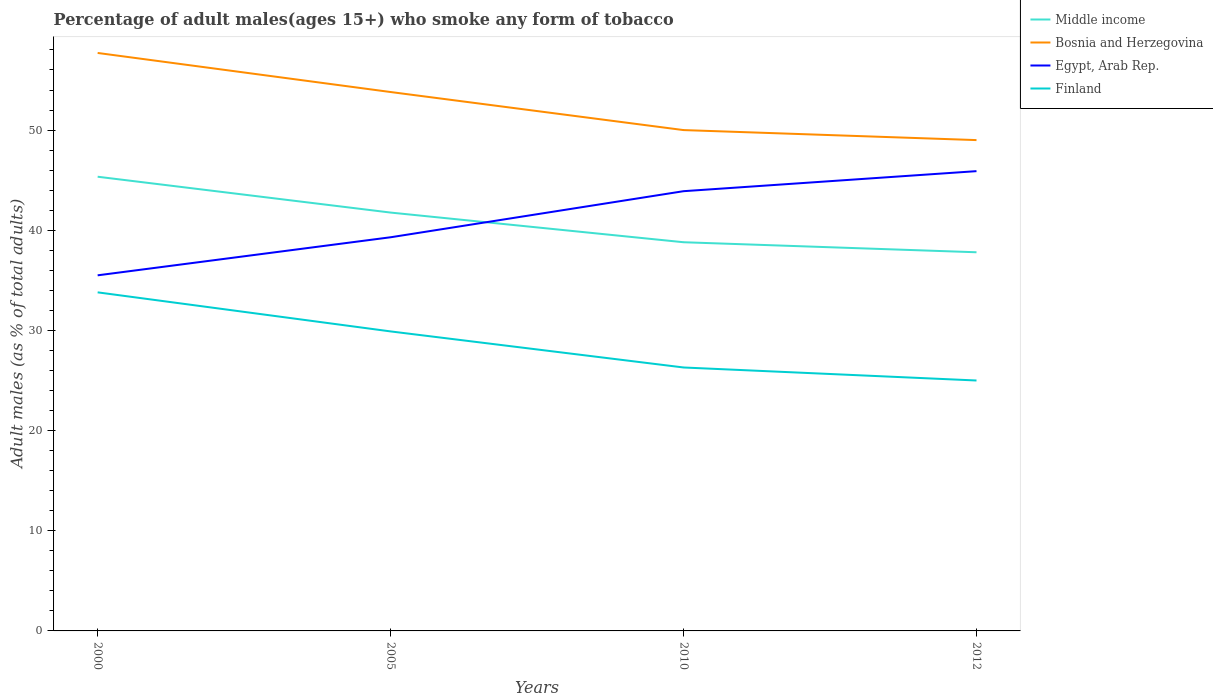How many different coloured lines are there?
Your response must be concise. 4. Does the line corresponding to Bosnia and Herzegovina intersect with the line corresponding to Middle income?
Ensure brevity in your answer.  No. Across all years, what is the maximum percentage of adult males who smoke in Middle income?
Your answer should be very brief. 37.8. What is the total percentage of adult males who smoke in Middle income in the graph?
Give a very brief answer. 2.96. What is the difference between the highest and the second highest percentage of adult males who smoke in Middle income?
Your answer should be very brief. 7.54. How many years are there in the graph?
Make the answer very short. 4. What is the title of the graph?
Provide a short and direct response. Percentage of adult males(ages 15+) who smoke any form of tobacco. What is the label or title of the X-axis?
Ensure brevity in your answer.  Years. What is the label or title of the Y-axis?
Ensure brevity in your answer.  Adult males (as % of total adults). What is the Adult males (as % of total adults) in Middle income in 2000?
Provide a short and direct response. 45.34. What is the Adult males (as % of total adults) of Bosnia and Herzegovina in 2000?
Provide a short and direct response. 57.7. What is the Adult males (as % of total adults) of Egypt, Arab Rep. in 2000?
Your answer should be very brief. 35.5. What is the Adult males (as % of total adults) of Finland in 2000?
Offer a terse response. 33.8. What is the Adult males (as % of total adults) of Middle income in 2005?
Your answer should be very brief. 41.77. What is the Adult males (as % of total adults) of Bosnia and Herzegovina in 2005?
Your answer should be very brief. 53.8. What is the Adult males (as % of total adults) of Egypt, Arab Rep. in 2005?
Offer a terse response. 39.3. What is the Adult males (as % of total adults) of Finland in 2005?
Give a very brief answer. 29.9. What is the Adult males (as % of total adults) of Middle income in 2010?
Give a very brief answer. 38.8. What is the Adult males (as % of total adults) of Egypt, Arab Rep. in 2010?
Ensure brevity in your answer.  43.9. What is the Adult males (as % of total adults) of Finland in 2010?
Keep it short and to the point. 26.3. What is the Adult males (as % of total adults) in Middle income in 2012?
Your answer should be compact. 37.8. What is the Adult males (as % of total adults) in Egypt, Arab Rep. in 2012?
Ensure brevity in your answer.  45.9. What is the Adult males (as % of total adults) of Finland in 2012?
Give a very brief answer. 25. Across all years, what is the maximum Adult males (as % of total adults) of Middle income?
Provide a succinct answer. 45.34. Across all years, what is the maximum Adult males (as % of total adults) in Bosnia and Herzegovina?
Provide a succinct answer. 57.7. Across all years, what is the maximum Adult males (as % of total adults) in Egypt, Arab Rep.?
Your answer should be compact. 45.9. Across all years, what is the maximum Adult males (as % of total adults) in Finland?
Provide a succinct answer. 33.8. Across all years, what is the minimum Adult males (as % of total adults) in Middle income?
Your answer should be compact. 37.8. Across all years, what is the minimum Adult males (as % of total adults) in Bosnia and Herzegovina?
Provide a short and direct response. 49. Across all years, what is the minimum Adult males (as % of total adults) in Egypt, Arab Rep.?
Your answer should be very brief. 35.5. Across all years, what is the minimum Adult males (as % of total adults) in Finland?
Make the answer very short. 25. What is the total Adult males (as % of total adults) in Middle income in the graph?
Make the answer very short. 163.71. What is the total Adult males (as % of total adults) of Bosnia and Herzegovina in the graph?
Offer a very short reply. 210.5. What is the total Adult males (as % of total adults) in Egypt, Arab Rep. in the graph?
Ensure brevity in your answer.  164.6. What is the total Adult males (as % of total adults) in Finland in the graph?
Your response must be concise. 115. What is the difference between the Adult males (as % of total adults) of Middle income in 2000 and that in 2005?
Ensure brevity in your answer.  3.58. What is the difference between the Adult males (as % of total adults) of Egypt, Arab Rep. in 2000 and that in 2005?
Your answer should be very brief. -3.8. What is the difference between the Adult males (as % of total adults) of Finland in 2000 and that in 2005?
Give a very brief answer. 3.9. What is the difference between the Adult males (as % of total adults) of Middle income in 2000 and that in 2010?
Provide a succinct answer. 6.54. What is the difference between the Adult males (as % of total adults) of Bosnia and Herzegovina in 2000 and that in 2010?
Your answer should be compact. 7.7. What is the difference between the Adult males (as % of total adults) in Middle income in 2000 and that in 2012?
Ensure brevity in your answer.  7.54. What is the difference between the Adult males (as % of total adults) in Bosnia and Herzegovina in 2000 and that in 2012?
Keep it short and to the point. 8.7. What is the difference between the Adult males (as % of total adults) of Finland in 2000 and that in 2012?
Your response must be concise. 8.8. What is the difference between the Adult males (as % of total adults) in Middle income in 2005 and that in 2010?
Give a very brief answer. 2.96. What is the difference between the Adult males (as % of total adults) in Bosnia and Herzegovina in 2005 and that in 2010?
Your response must be concise. 3.8. What is the difference between the Adult males (as % of total adults) of Finland in 2005 and that in 2010?
Your answer should be compact. 3.6. What is the difference between the Adult males (as % of total adults) in Middle income in 2005 and that in 2012?
Give a very brief answer. 3.96. What is the difference between the Adult males (as % of total adults) of Bosnia and Herzegovina in 2005 and that in 2012?
Offer a terse response. 4.8. What is the difference between the Adult males (as % of total adults) in Finland in 2005 and that in 2012?
Offer a terse response. 4.9. What is the difference between the Adult males (as % of total adults) in Finland in 2010 and that in 2012?
Your answer should be very brief. 1.3. What is the difference between the Adult males (as % of total adults) of Middle income in 2000 and the Adult males (as % of total adults) of Bosnia and Herzegovina in 2005?
Give a very brief answer. -8.46. What is the difference between the Adult males (as % of total adults) of Middle income in 2000 and the Adult males (as % of total adults) of Egypt, Arab Rep. in 2005?
Your answer should be compact. 6.04. What is the difference between the Adult males (as % of total adults) of Middle income in 2000 and the Adult males (as % of total adults) of Finland in 2005?
Make the answer very short. 15.44. What is the difference between the Adult males (as % of total adults) of Bosnia and Herzegovina in 2000 and the Adult males (as % of total adults) of Finland in 2005?
Offer a terse response. 27.8. What is the difference between the Adult males (as % of total adults) in Middle income in 2000 and the Adult males (as % of total adults) in Bosnia and Herzegovina in 2010?
Your answer should be compact. -4.66. What is the difference between the Adult males (as % of total adults) of Middle income in 2000 and the Adult males (as % of total adults) of Egypt, Arab Rep. in 2010?
Keep it short and to the point. 1.44. What is the difference between the Adult males (as % of total adults) in Middle income in 2000 and the Adult males (as % of total adults) in Finland in 2010?
Provide a succinct answer. 19.04. What is the difference between the Adult males (as % of total adults) in Bosnia and Herzegovina in 2000 and the Adult males (as % of total adults) in Egypt, Arab Rep. in 2010?
Give a very brief answer. 13.8. What is the difference between the Adult males (as % of total adults) of Bosnia and Herzegovina in 2000 and the Adult males (as % of total adults) of Finland in 2010?
Your answer should be very brief. 31.4. What is the difference between the Adult males (as % of total adults) in Egypt, Arab Rep. in 2000 and the Adult males (as % of total adults) in Finland in 2010?
Keep it short and to the point. 9.2. What is the difference between the Adult males (as % of total adults) of Middle income in 2000 and the Adult males (as % of total adults) of Bosnia and Herzegovina in 2012?
Your answer should be compact. -3.66. What is the difference between the Adult males (as % of total adults) of Middle income in 2000 and the Adult males (as % of total adults) of Egypt, Arab Rep. in 2012?
Make the answer very short. -0.56. What is the difference between the Adult males (as % of total adults) in Middle income in 2000 and the Adult males (as % of total adults) in Finland in 2012?
Give a very brief answer. 20.34. What is the difference between the Adult males (as % of total adults) in Bosnia and Herzegovina in 2000 and the Adult males (as % of total adults) in Finland in 2012?
Make the answer very short. 32.7. What is the difference between the Adult males (as % of total adults) in Egypt, Arab Rep. in 2000 and the Adult males (as % of total adults) in Finland in 2012?
Give a very brief answer. 10.5. What is the difference between the Adult males (as % of total adults) in Middle income in 2005 and the Adult males (as % of total adults) in Bosnia and Herzegovina in 2010?
Your response must be concise. -8.23. What is the difference between the Adult males (as % of total adults) in Middle income in 2005 and the Adult males (as % of total adults) in Egypt, Arab Rep. in 2010?
Ensure brevity in your answer.  -2.13. What is the difference between the Adult males (as % of total adults) of Middle income in 2005 and the Adult males (as % of total adults) of Finland in 2010?
Provide a succinct answer. 15.47. What is the difference between the Adult males (as % of total adults) in Egypt, Arab Rep. in 2005 and the Adult males (as % of total adults) in Finland in 2010?
Your response must be concise. 13. What is the difference between the Adult males (as % of total adults) of Middle income in 2005 and the Adult males (as % of total adults) of Bosnia and Herzegovina in 2012?
Make the answer very short. -7.23. What is the difference between the Adult males (as % of total adults) in Middle income in 2005 and the Adult males (as % of total adults) in Egypt, Arab Rep. in 2012?
Ensure brevity in your answer.  -4.13. What is the difference between the Adult males (as % of total adults) of Middle income in 2005 and the Adult males (as % of total adults) of Finland in 2012?
Offer a terse response. 16.77. What is the difference between the Adult males (as % of total adults) of Bosnia and Herzegovina in 2005 and the Adult males (as % of total adults) of Egypt, Arab Rep. in 2012?
Ensure brevity in your answer.  7.9. What is the difference between the Adult males (as % of total adults) in Bosnia and Herzegovina in 2005 and the Adult males (as % of total adults) in Finland in 2012?
Offer a very short reply. 28.8. What is the difference between the Adult males (as % of total adults) of Middle income in 2010 and the Adult males (as % of total adults) of Bosnia and Herzegovina in 2012?
Provide a short and direct response. -10.2. What is the difference between the Adult males (as % of total adults) in Middle income in 2010 and the Adult males (as % of total adults) in Egypt, Arab Rep. in 2012?
Offer a very short reply. -7.1. What is the difference between the Adult males (as % of total adults) in Middle income in 2010 and the Adult males (as % of total adults) in Finland in 2012?
Provide a short and direct response. 13.8. What is the difference between the Adult males (as % of total adults) in Bosnia and Herzegovina in 2010 and the Adult males (as % of total adults) in Egypt, Arab Rep. in 2012?
Offer a terse response. 4.1. What is the difference between the Adult males (as % of total adults) of Bosnia and Herzegovina in 2010 and the Adult males (as % of total adults) of Finland in 2012?
Offer a very short reply. 25. What is the difference between the Adult males (as % of total adults) of Egypt, Arab Rep. in 2010 and the Adult males (as % of total adults) of Finland in 2012?
Offer a terse response. 18.9. What is the average Adult males (as % of total adults) in Middle income per year?
Ensure brevity in your answer.  40.93. What is the average Adult males (as % of total adults) in Bosnia and Herzegovina per year?
Your answer should be compact. 52.62. What is the average Adult males (as % of total adults) in Egypt, Arab Rep. per year?
Keep it short and to the point. 41.15. What is the average Adult males (as % of total adults) of Finland per year?
Give a very brief answer. 28.75. In the year 2000, what is the difference between the Adult males (as % of total adults) in Middle income and Adult males (as % of total adults) in Bosnia and Herzegovina?
Provide a succinct answer. -12.36. In the year 2000, what is the difference between the Adult males (as % of total adults) in Middle income and Adult males (as % of total adults) in Egypt, Arab Rep.?
Ensure brevity in your answer.  9.84. In the year 2000, what is the difference between the Adult males (as % of total adults) in Middle income and Adult males (as % of total adults) in Finland?
Ensure brevity in your answer.  11.54. In the year 2000, what is the difference between the Adult males (as % of total adults) in Bosnia and Herzegovina and Adult males (as % of total adults) in Finland?
Ensure brevity in your answer.  23.9. In the year 2005, what is the difference between the Adult males (as % of total adults) in Middle income and Adult males (as % of total adults) in Bosnia and Herzegovina?
Your response must be concise. -12.03. In the year 2005, what is the difference between the Adult males (as % of total adults) in Middle income and Adult males (as % of total adults) in Egypt, Arab Rep.?
Keep it short and to the point. 2.47. In the year 2005, what is the difference between the Adult males (as % of total adults) in Middle income and Adult males (as % of total adults) in Finland?
Your response must be concise. 11.87. In the year 2005, what is the difference between the Adult males (as % of total adults) in Bosnia and Herzegovina and Adult males (as % of total adults) in Egypt, Arab Rep.?
Your response must be concise. 14.5. In the year 2005, what is the difference between the Adult males (as % of total adults) in Bosnia and Herzegovina and Adult males (as % of total adults) in Finland?
Provide a short and direct response. 23.9. In the year 2010, what is the difference between the Adult males (as % of total adults) of Middle income and Adult males (as % of total adults) of Bosnia and Herzegovina?
Your response must be concise. -11.2. In the year 2010, what is the difference between the Adult males (as % of total adults) in Middle income and Adult males (as % of total adults) in Egypt, Arab Rep.?
Your answer should be compact. -5.1. In the year 2010, what is the difference between the Adult males (as % of total adults) of Middle income and Adult males (as % of total adults) of Finland?
Offer a terse response. 12.5. In the year 2010, what is the difference between the Adult males (as % of total adults) in Bosnia and Herzegovina and Adult males (as % of total adults) in Egypt, Arab Rep.?
Your answer should be very brief. 6.1. In the year 2010, what is the difference between the Adult males (as % of total adults) of Bosnia and Herzegovina and Adult males (as % of total adults) of Finland?
Your answer should be very brief. 23.7. In the year 2012, what is the difference between the Adult males (as % of total adults) in Middle income and Adult males (as % of total adults) in Bosnia and Herzegovina?
Make the answer very short. -11.2. In the year 2012, what is the difference between the Adult males (as % of total adults) in Middle income and Adult males (as % of total adults) in Egypt, Arab Rep.?
Your answer should be compact. -8.1. In the year 2012, what is the difference between the Adult males (as % of total adults) in Middle income and Adult males (as % of total adults) in Finland?
Offer a very short reply. 12.8. In the year 2012, what is the difference between the Adult males (as % of total adults) of Bosnia and Herzegovina and Adult males (as % of total adults) of Egypt, Arab Rep.?
Your answer should be very brief. 3.1. In the year 2012, what is the difference between the Adult males (as % of total adults) of Bosnia and Herzegovina and Adult males (as % of total adults) of Finland?
Ensure brevity in your answer.  24. In the year 2012, what is the difference between the Adult males (as % of total adults) of Egypt, Arab Rep. and Adult males (as % of total adults) of Finland?
Keep it short and to the point. 20.9. What is the ratio of the Adult males (as % of total adults) of Middle income in 2000 to that in 2005?
Your response must be concise. 1.09. What is the ratio of the Adult males (as % of total adults) of Bosnia and Herzegovina in 2000 to that in 2005?
Your answer should be compact. 1.07. What is the ratio of the Adult males (as % of total adults) in Egypt, Arab Rep. in 2000 to that in 2005?
Offer a very short reply. 0.9. What is the ratio of the Adult males (as % of total adults) in Finland in 2000 to that in 2005?
Offer a very short reply. 1.13. What is the ratio of the Adult males (as % of total adults) of Middle income in 2000 to that in 2010?
Offer a terse response. 1.17. What is the ratio of the Adult males (as % of total adults) of Bosnia and Herzegovina in 2000 to that in 2010?
Keep it short and to the point. 1.15. What is the ratio of the Adult males (as % of total adults) in Egypt, Arab Rep. in 2000 to that in 2010?
Your answer should be very brief. 0.81. What is the ratio of the Adult males (as % of total adults) of Finland in 2000 to that in 2010?
Your response must be concise. 1.29. What is the ratio of the Adult males (as % of total adults) in Middle income in 2000 to that in 2012?
Offer a terse response. 1.2. What is the ratio of the Adult males (as % of total adults) in Bosnia and Herzegovina in 2000 to that in 2012?
Offer a very short reply. 1.18. What is the ratio of the Adult males (as % of total adults) in Egypt, Arab Rep. in 2000 to that in 2012?
Provide a succinct answer. 0.77. What is the ratio of the Adult males (as % of total adults) in Finland in 2000 to that in 2012?
Your answer should be very brief. 1.35. What is the ratio of the Adult males (as % of total adults) of Middle income in 2005 to that in 2010?
Make the answer very short. 1.08. What is the ratio of the Adult males (as % of total adults) of Bosnia and Herzegovina in 2005 to that in 2010?
Your answer should be very brief. 1.08. What is the ratio of the Adult males (as % of total adults) of Egypt, Arab Rep. in 2005 to that in 2010?
Make the answer very short. 0.9. What is the ratio of the Adult males (as % of total adults) of Finland in 2005 to that in 2010?
Your answer should be very brief. 1.14. What is the ratio of the Adult males (as % of total adults) of Middle income in 2005 to that in 2012?
Your response must be concise. 1.1. What is the ratio of the Adult males (as % of total adults) in Bosnia and Herzegovina in 2005 to that in 2012?
Your response must be concise. 1.1. What is the ratio of the Adult males (as % of total adults) of Egypt, Arab Rep. in 2005 to that in 2012?
Keep it short and to the point. 0.86. What is the ratio of the Adult males (as % of total adults) of Finland in 2005 to that in 2012?
Your answer should be very brief. 1.2. What is the ratio of the Adult males (as % of total adults) of Middle income in 2010 to that in 2012?
Your answer should be compact. 1.03. What is the ratio of the Adult males (as % of total adults) in Bosnia and Herzegovina in 2010 to that in 2012?
Offer a very short reply. 1.02. What is the ratio of the Adult males (as % of total adults) in Egypt, Arab Rep. in 2010 to that in 2012?
Ensure brevity in your answer.  0.96. What is the ratio of the Adult males (as % of total adults) of Finland in 2010 to that in 2012?
Offer a terse response. 1.05. What is the difference between the highest and the second highest Adult males (as % of total adults) in Middle income?
Your answer should be very brief. 3.58. What is the difference between the highest and the second highest Adult males (as % of total adults) in Bosnia and Herzegovina?
Provide a succinct answer. 3.9. What is the difference between the highest and the lowest Adult males (as % of total adults) of Middle income?
Your response must be concise. 7.54. What is the difference between the highest and the lowest Adult males (as % of total adults) in Egypt, Arab Rep.?
Ensure brevity in your answer.  10.4. What is the difference between the highest and the lowest Adult males (as % of total adults) in Finland?
Keep it short and to the point. 8.8. 